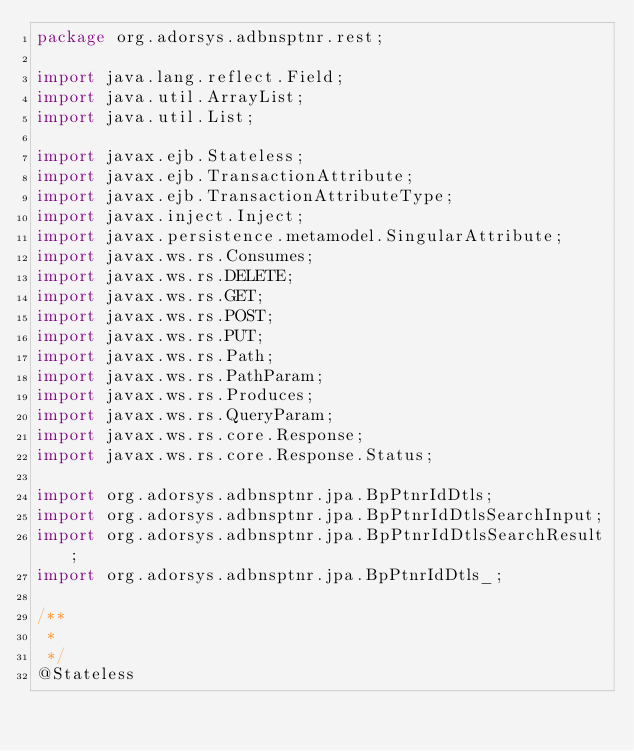Convert code to text. <code><loc_0><loc_0><loc_500><loc_500><_Java_>package org.adorsys.adbnsptnr.rest;

import java.lang.reflect.Field;
import java.util.ArrayList;
import java.util.List;

import javax.ejb.Stateless;
import javax.ejb.TransactionAttribute;
import javax.ejb.TransactionAttributeType;
import javax.inject.Inject;
import javax.persistence.metamodel.SingularAttribute;
import javax.ws.rs.Consumes;
import javax.ws.rs.DELETE;
import javax.ws.rs.GET;
import javax.ws.rs.POST;
import javax.ws.rs.PUT;
import javax.ws.rs.Path;
import javax.ws.rs.PathParam;
import javax.ws.rs.Produces;
import javax.ws.rs.QueryParam;
import javax.ws.rs.core.Response;
import javax.ws.rs.core.Response.Status;

import org.adorsys.adbnsptnr.jpa.BpPtnrIdDtls;
import org.adorsys.adbnsptnr.jpa.BpPtnrIdDtlsSearchInput;
import org.adorsys.adbnsptnr.jpa.BpPtnrIdDtlsSearchResult;
import org.adorsys.adbnsptnr.jpa.BpPtnrIdDtls_;

/**
 * 
 */
@Stateless</code> 